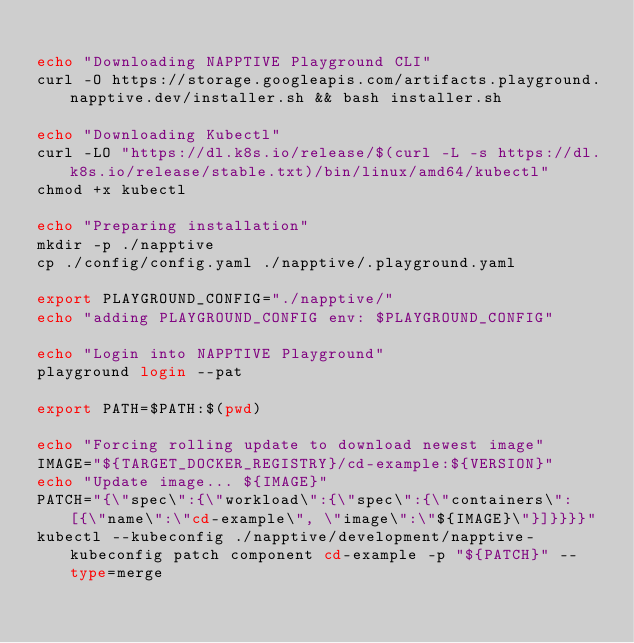Convert code to text. <code><loc_0><loc_0><loc_500><loc_500><_Bash_>
echo "Downloading NAPPTIVE Playground CLI"
curl -O https://storage.googleapis.com/artifacts.playground.napptive.dev/installer.sh && bash installer.sh

echo "Downloading Kubectl"
curl -LO "https://dl.k8s.io/release/$(curl -L -s https://dl.k8s.io/release/stable.txt)/bin/linux/amd64/kubectl"
chmod +x kubectl

echo "Preparing installation"
mkdir -p ./napptive
cp ./config/config.yaml ./napptive/.playground.yaml

export PLAYGROUND_CONFIG="./napptive/"
echo "adding PLAYGROUND_CONFIG env: $PLAYGROUND_CONFIG"

echo "Login into NAPPTIVE Playground"
playground login --pat 

export PATH=$PATH:$(pwd)

echo "Forcing rolling update to download newest image"
IMAGE="${TARGET_DOCKER_REGISTRY}/cd-example:${VERSION}"
echo "Update image... ${IMAGE}"
PATCH="{\"spec\":{\"workload\":{\"spec\":{\"containers\": [{\"name\":\"cd-example\", \"image\":\"${IMAGE}\"}]}}}}"
kubectl --kubeconfig ./napptive/development/napptive-kubeconfig patch component cd-example -p "${PATCH}" --type=merge
</code> 